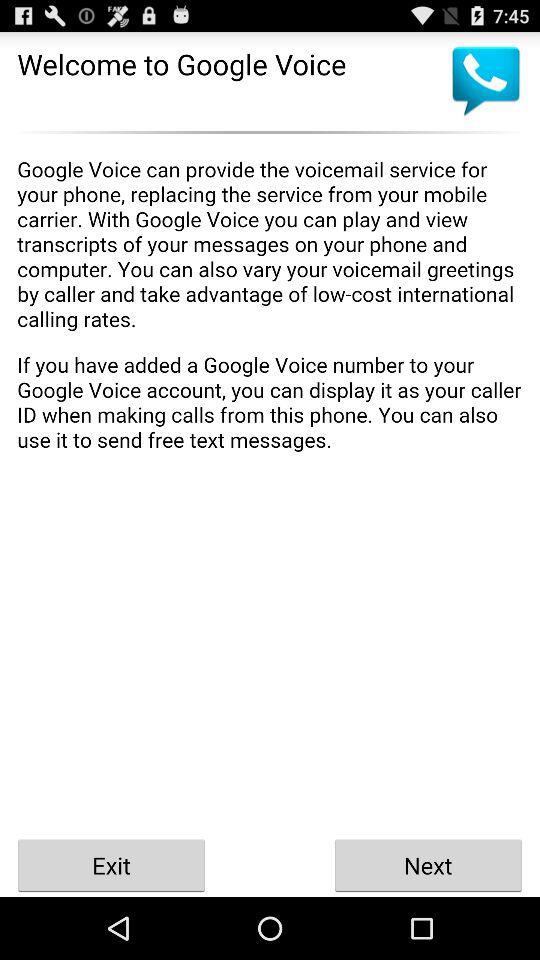What is Google's voice?
When the provided information is insufficient, respond with <no answer>. <no answer> 